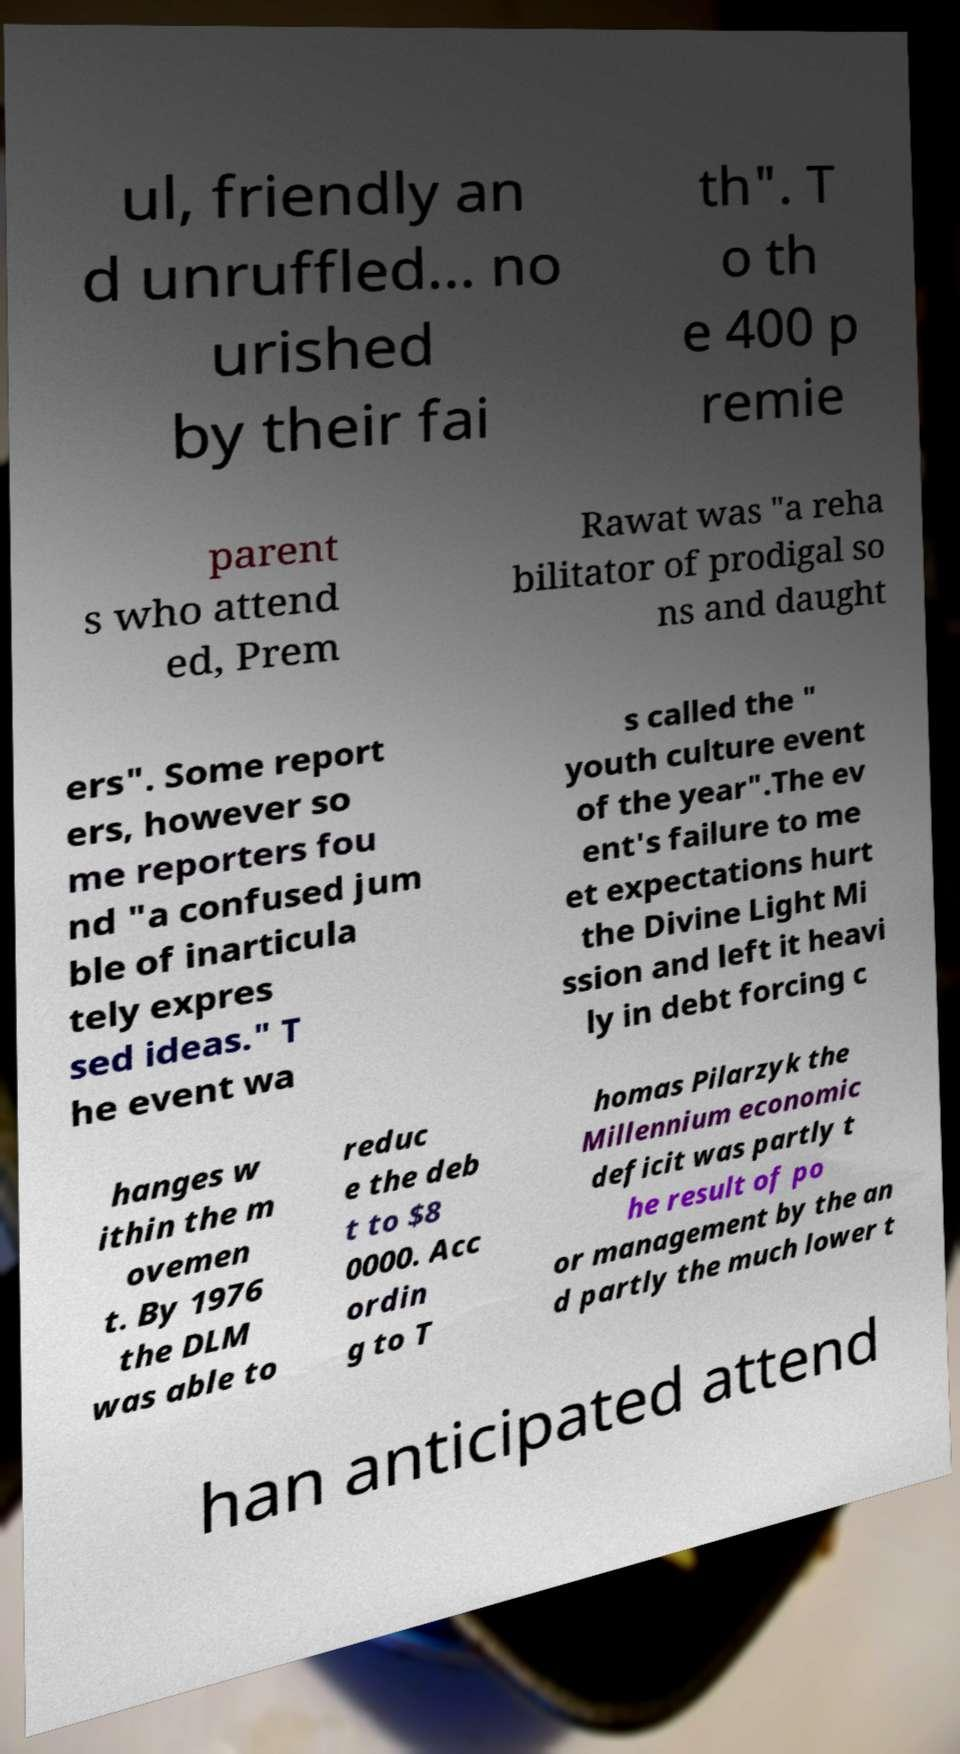For documentation purposes, I need the text within this image transcribed. Could you provide that? ul, friendly an d unruffled... no urished by their fai th". T o th e 400 p remie parent s who attend ed, Prem Rawat was "a reha bilitator of prodigal so ns and daught ers". Some report ers, however so me reporters fou nd "a confused jum ble of inarticula tely expres sed ideas." T he event wa s called the " youth culture event of the year".The ev ent's failure to me et expectations hurt the Divine Light Mi ssion and left it heavi ly in debt forcing c hanges w ithin the m ovemen t. By 1976 the DLM was able to reduc e the deb t to $8 0000. Acc ordin g to T homas Pilarzyk the Millennium economic deficit was partly t he result of po or management by the an d partly the much lower t han anticipated attend 